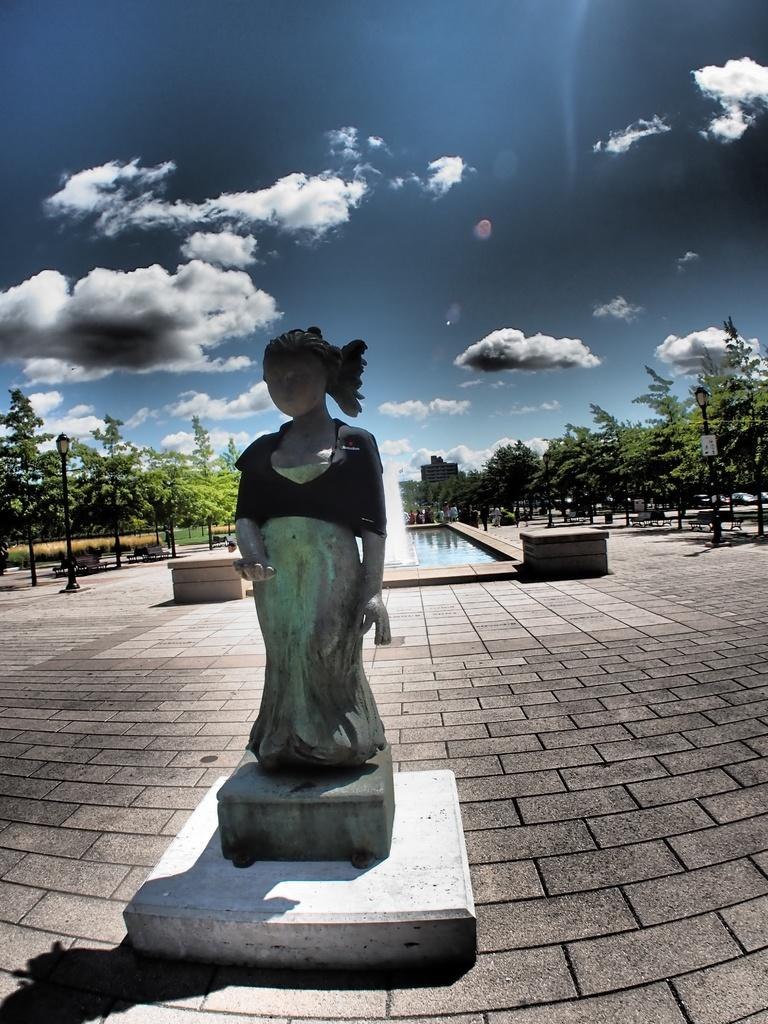What is the main subject of the image? There is a sculpture of a woman in the image. Where is the sculpture located? The sculpture is on a stone path. What other elements can be seen in the image? There is a pool with water, trees, and the sky visible in the image. What is the condition of the sky in the image? The sky is visible with clouds present in the image. What is the tax rate for the use of the trail in the image? There is no trail present in the image, and therefore no tax rate can be determined. 